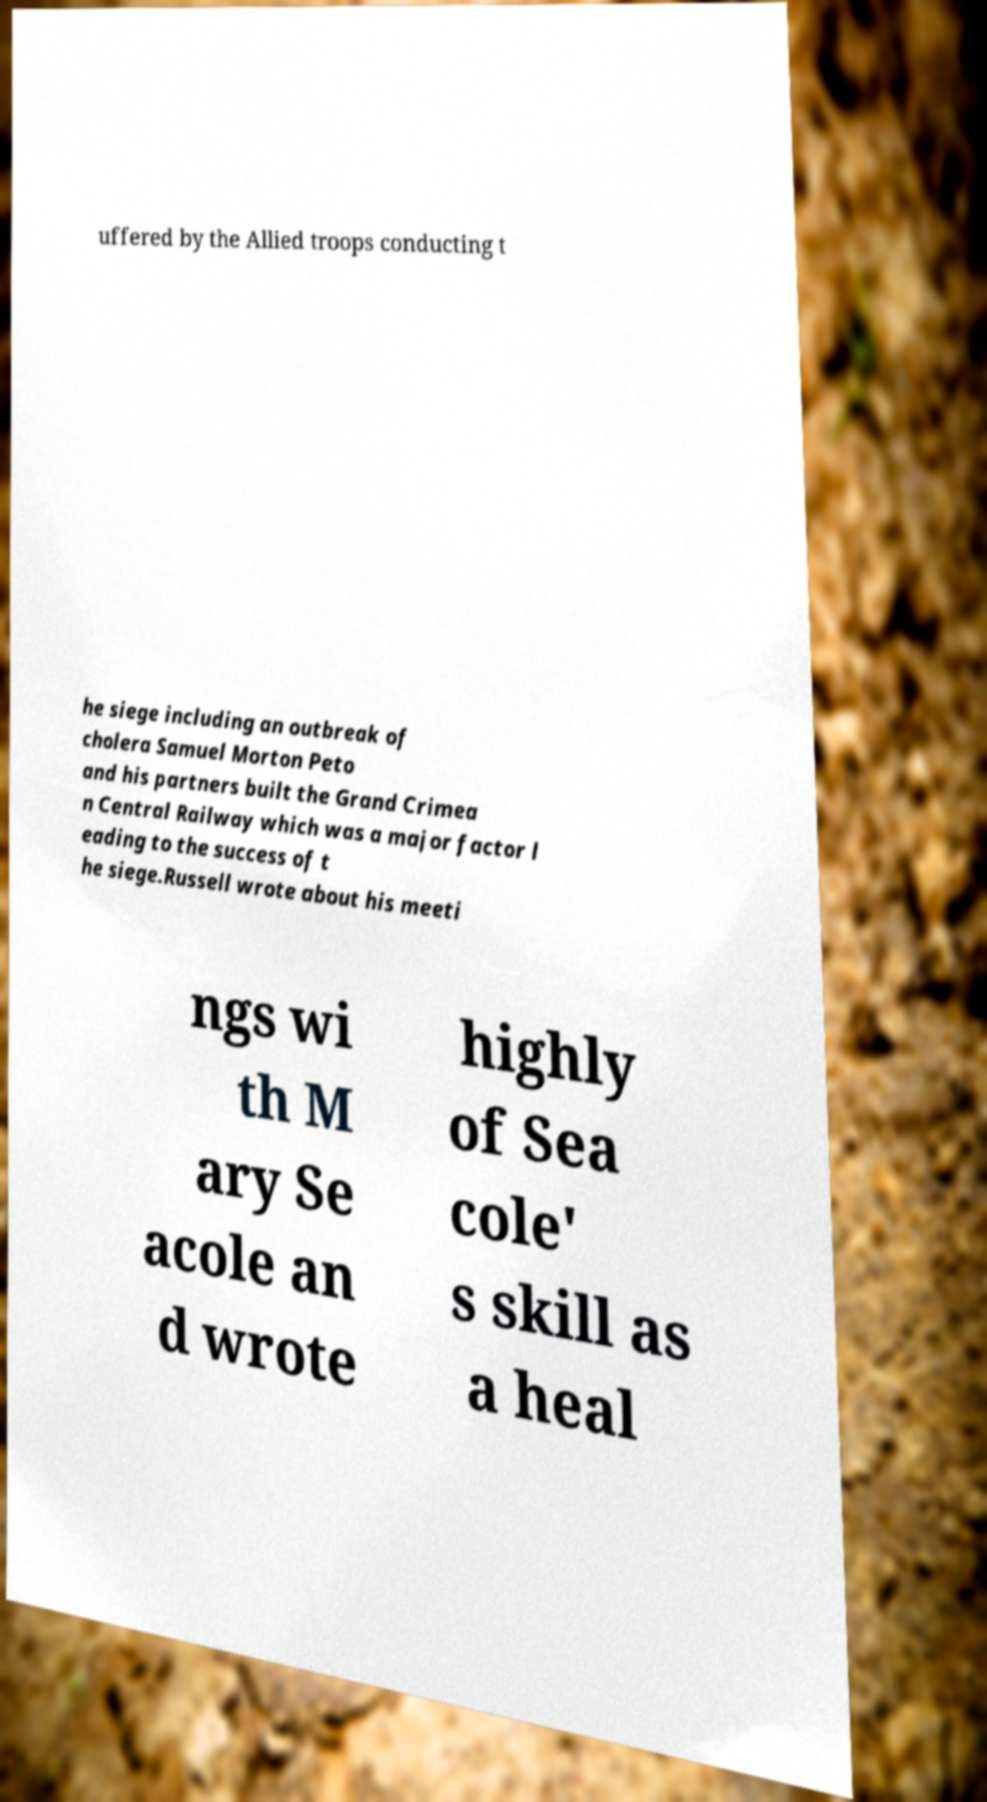What messages or text are displayed in this image? I need them in a readable, typed format. uffered by the Allied troops conducting t he siege including an outbreak of cholera Samuel Morton Peto and his partners built the Grand Crimea n Central Railway which was a major factor l eading to the success of t he siege.Russell wrote about his meeti ngs wi th M ary Se acole an d wrote highly of Sea cole' s skill as a heal 